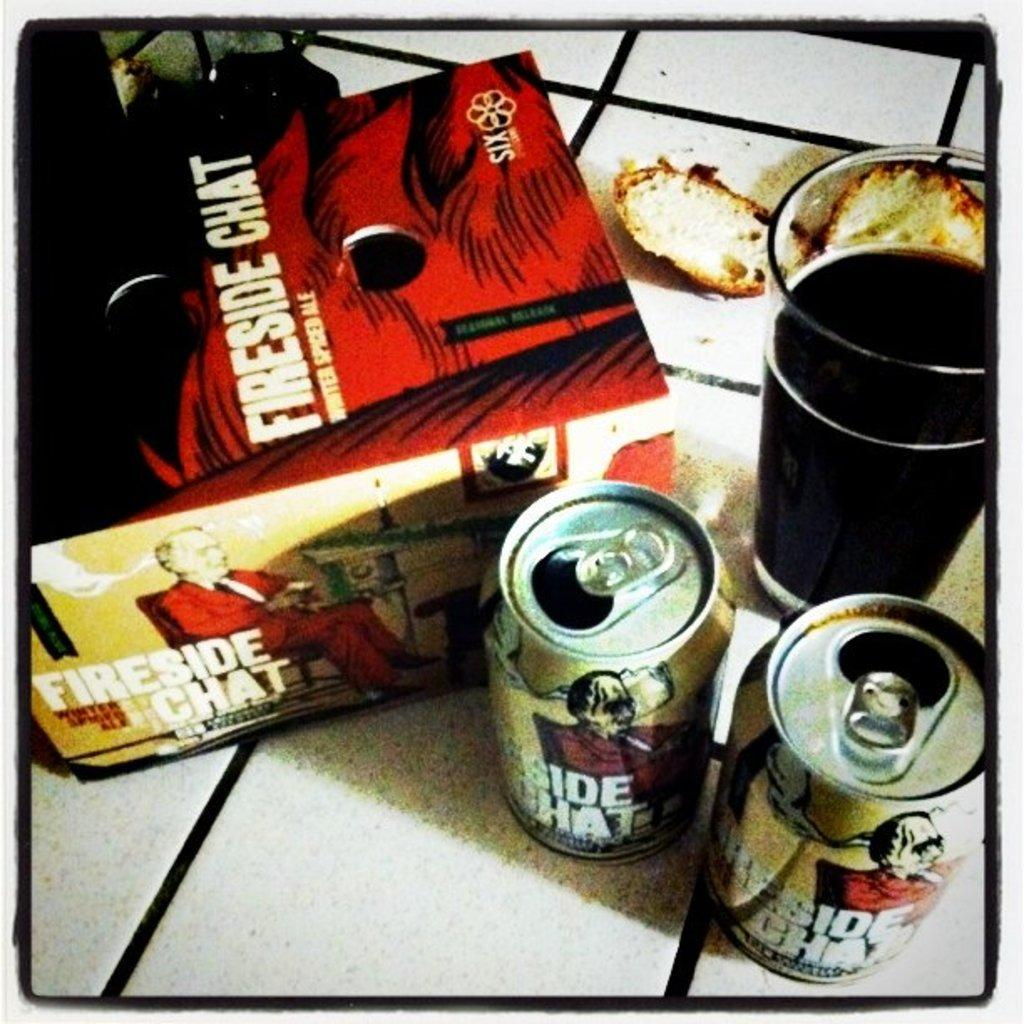<image>
Write a terse but informative summary of the picture. a fireside chat box with some cans next to it 